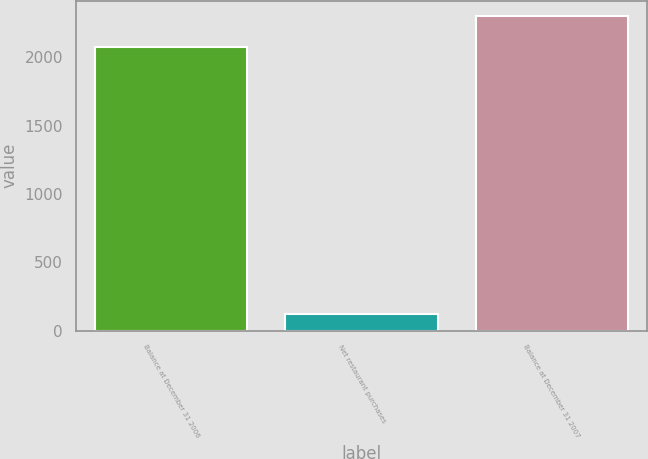Convert chart. <chart><loc_0><loc_0><loc_500><loc_500><bar_chart><fcel>Balance at December 31 2006<fcel>Net restaurant purchases<fcel>Balance at December 31 2007<nl><fcel>2073.6<fcel>124.7<fcel>2301.3<nl></chart> 